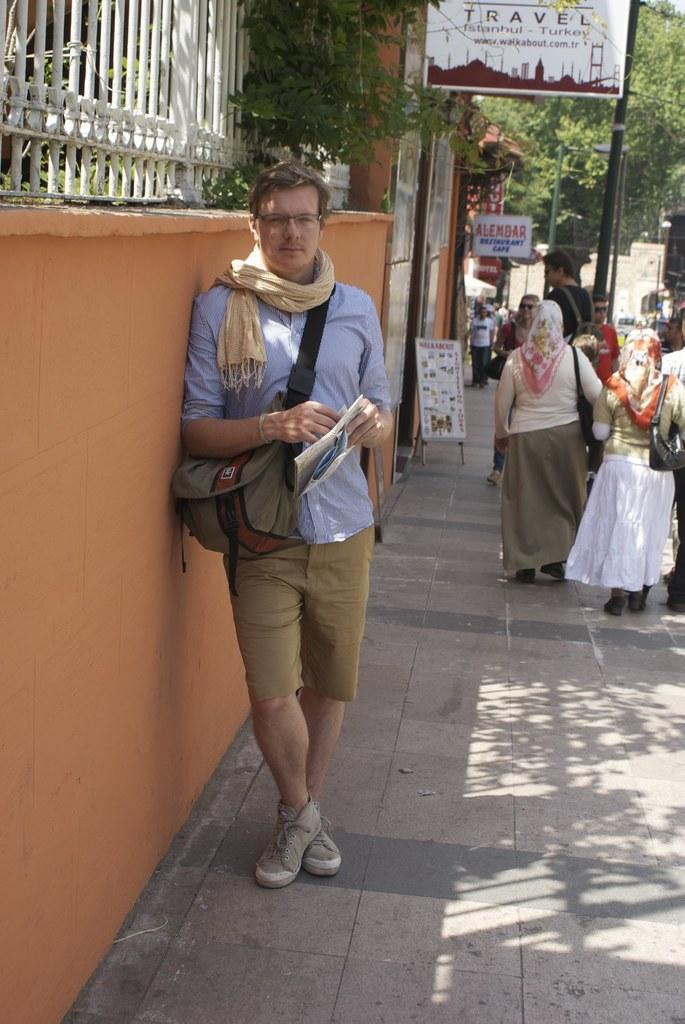Can you describe this image briefly? In the picture there is a wall, there is an iron fence on the wall, beside the wall there are many people standing on the floor, there are trees, there are boards with the text and there are poles. 